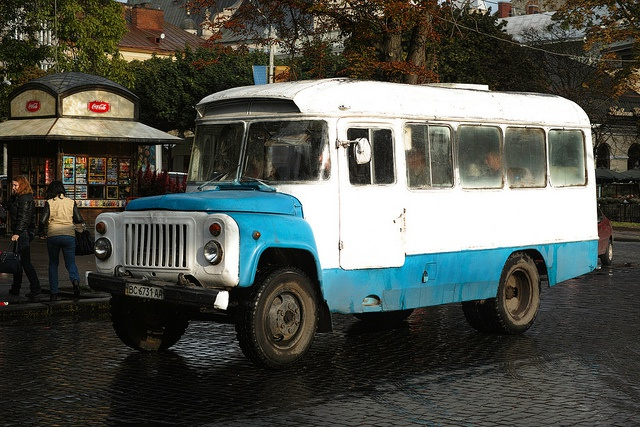Describe the objects in this image and their specific colors. I can see truck in darkgreen, white, black, gray, and darkgray tones, bus in darkgreen, white, black, gray, and darkgray tones, people in darkgreen, black, and tan tones, people in darkgreen, black, maroon, and brown tones, and people in darkgreen, gray, and black tones in this image. 